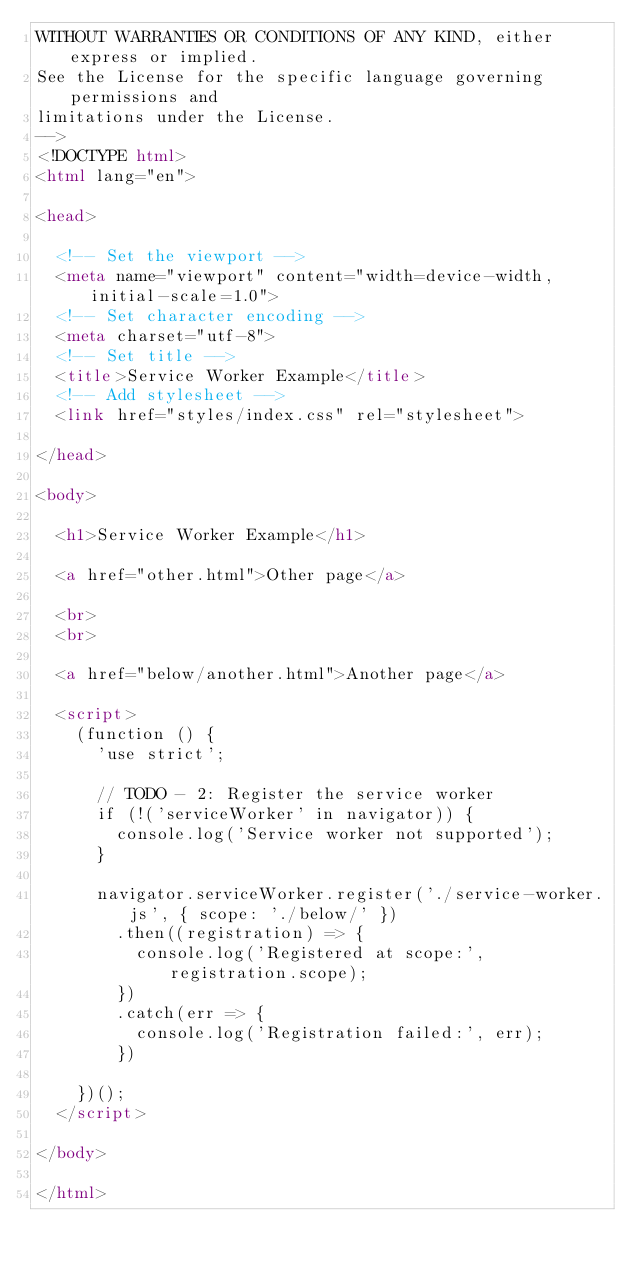<code> <loc_0><loc_0><loc_500><loc_500><_HTML_>WITHOUT WARRANTIES OR CONDITIONS OF ANY KIND, either express or implied.
See the License for the specific language governing permissions and
limitations under the License.
-->
<!DOCTYPE html>
<html lang="en">

<head>

  <!-- Set the viewport -->
  <meta name="viewport" content="width=device-width, initial-scale=1.0">
  <!-- Set character encoding -->
  <meta charset="utf-8">
  <!-- Set title -->
  <title>Service Worker Example</title>
  <!-- Add stylesheet -->
  <link href="styles/index.css" rel="stylesheet">

</head>

<body>

  <h1>Service Worker Example</h1>

  <a href="other.html">Other page</a>

  <br>
  <br>

  <a href="below/another.html">Another page</a>

  <script>
    (function () {
      'use strict';

      // TODO - 2: Register the service worker
      if (!('serviceWorker' in navigator)) {
        console.log('Service worker not supported');
      }

      navigator.serviceWorker.register('./service-worker.js', { scope: './below/' })
        .then((registration) => {
          console.log('Registered at scope:', registration.scope);
        })
        .catch(err => {
          console.log('Registration failed:', err);
        })

    })();
  </script>

</body>

</html></code> 